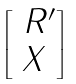Convert formula to latex. <formula><loc_0><loc_0><loc_500><loc_500>\begin{bmatrix} \ R ^ { \prime } \\ X \end{bmatrix}</formula> 